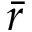Convert formula to latex. <formula><loc_0><loc_0><loc_500><loc_500>\bar { r }</formula> 